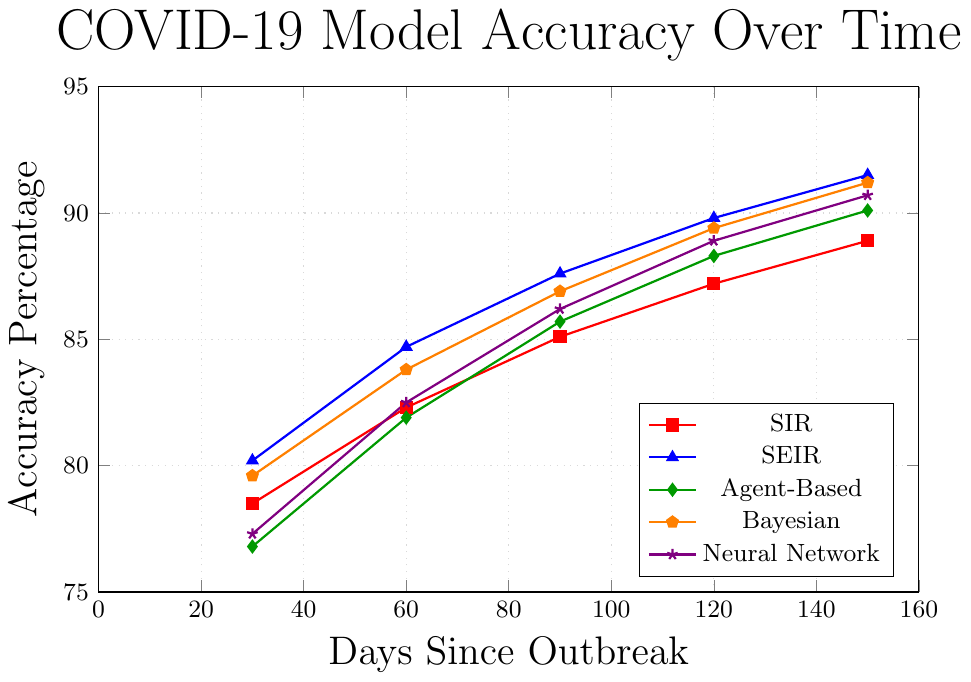Which model has the highest accuracy at 150 days since the outbreak? By examining the value of accuracy at 150 days for all models, we see SEIR has the highest accuracy at 91.5%.
Answer: SEIR Which model performed the worst at 30 days? By looking at the accuracy values at 30 days, the Agent-Based model has the lowest accuracy at 76.8%.
Answer: Agent-Based How does the accuracy of the Bayesian model at 90 days compare to the Neural Network model at 120 days? The Bayesian model has an accuracy of 86.9% at 90 days, while the Neural Network model has an accuracy of 88.9% at 120 days. Comparing these values, 86.9% is less than 88.9%.
Answer: Less than What is the average accuracy of the SIR model across all observed days? The accuracies of the SIR model are 78.5, 82.3, 85.1, 87.2, and 88.9. Adding these gives a total of 421.9, and dividing by 5 gives an average of 421.9 / 5 = 84.38%.
Answer: 84.38% Which model shows the greatest improvement in accuracy from 30 days to 120 days since the outbreak? The improvements from 30 to 120 days are: SIR (87.2 - 78.5 = 8.7), SEIR (89.8 - 80.2 = 9.6), Agent-Based (88.3 - 76.8 = 11.5), Bayesian (89.4 - 79.6 = 9.8), Neural Network (88.9 - 77.3 = 11.6). The Neural Network model shows the greatest improvement of 11.6%.
Answer: Neural Network What is the difference in accuracy between the SEIR and Bayesian models at 120 days? The accuracy of the SEIR model at 120 days is 89.8%, and the Bayesian model is 89.4%. The difference is 89.8% - 89.4% = 0.4%.
Answer: 0.4% Identify which model's accuracy increased the most between any two consecutive time points. Reviewing all data points for each time interval: SIR (3.8, 2.8, 2.1, 1.7), SEIR (4.5, 2.9, 2.2, 1.7), Agent-Based (5.1, 3.8, 2.6, 1.8), Bayesian (4.2, 3.1, 2.5, 1.8), Neural Network (5.2, 3.7, 2.7, 1.8), the largest increase is for the Neural Network model between 30 and 60 days at 5.2%.
Answer: Neural Network Which model had the closest accuracy to 85% at 90 days? At 90 days, the accuracies are SIR (85.1), SEIR (87.6), Agent-Based (85.7), Bayesian (86.9), Neural Network (86.2). Comparing these to 85%, the SIR model at 85.1% is the closest.
Answer: SIR What time interval shows the most overall accuracy improvement across all models? Adding the total improvements for each time interval: 30-60 (3.8 + 4.5 + 5.1 + 4.2 + 5.2 = 22.8), 60-90 (2.8 + 2.9 + 3.8 + 3.1 + 3.7 = 16.3), 90-120 (2.1 + 2.9 + 2.6 + 2.5 + 2.7 = 12.8), 120-150 (1.7 + 1.7 + 1.8 + 1.8 + 1.8 = 8.8). The 30-60 interval has the highest overall increase of 22.8%.
Answer: 30-60 days interval 